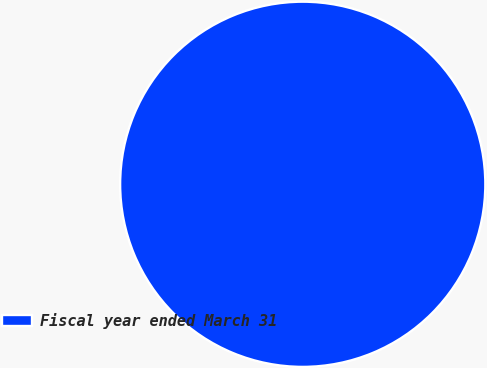Convert chart. <chart><loc_0><loc_0><loc_500><loc_500><pie_chart><fcel>Fiscal year ended March 31<nl><fcel>100.0%<nl></chart> 